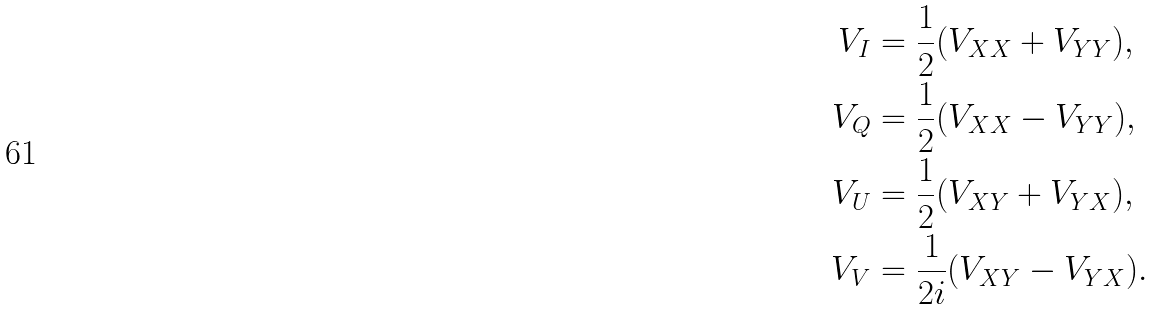Convert formula to latex. <formula><loc_0><loc_0><loc_500><loc_500>V _ { I } & = \frac { 1 } { 2 } ( V _ { X X } + V _ { Y Y } ) , \\ V _ { Q } & = \frac { 1 } { 2 } ( V _ { X X } - V _ { Y Y } ) , \\ V _ { U } & = \frac { 1 } { 2 } ( V _ { X Y } + V _ { Y X } ) , \\ V _ { V } & = \frac { 1 } { 2 i } ( V _ { X Y } - V _ { Y X } ) .</formula> 